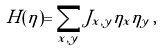<formula> <loc_0><loc_0><loc_500><loc_500>H ( \eta ) = \sum _ { x , y } J _ { x , y } \eta _ { x } \eta _ { y } \, ,</formula> 